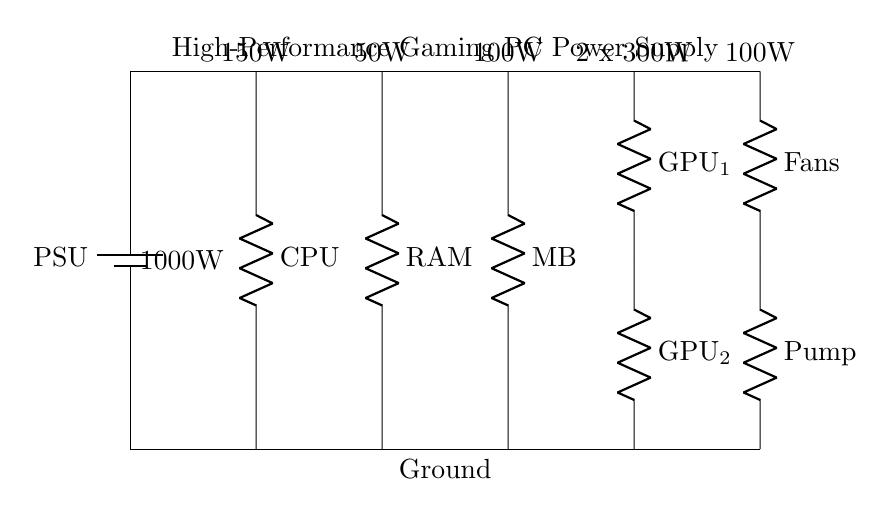what component provides power to the circuit? The component providing power to the circuit is the PSU, which stands for Power Supply Unit. This component is responsible for converting electrical power and distributing it to the various components of the gaming PC.
Answer: PSU how many GPUs are shown in the circuit diagram? The circuit diagram depicts two GPUs, labeled GPU_1 and GPU_2. Both are connected in series along the power rail.
Answer: 2 what is the total power rating of the GPUs? Each GPU has a power rating of 300W, so the total power for both GPUs is calculated by multiplying the power rating of one GPU by the number of GPUs: 300W x 2 = 600W.
Answer: 600W what is the power rating of the CPU in the circuit? The CPU's power rating is indicated as 150W in the diagram, which represents the amount of electrical power it requires for its operation.
Answer: 150W which component has the highest power rating? The component with the highest power rating in this circuit is the PSU, which has a rating of 1000W. This is the total power capacity available for the entire system.
Answer: 1000W how is the cooling system powered in this circuit? The cooling system, consisting of fans and a pump, receives power from the PSU as depicted in the circuit diagram. The fans are rated at 100W, and the pump also gets power from the same connection coming from the PSU.
Answer: PSU what is the total power consumption of the other components (excluding cooling and GPUs)? To calculate the total power consumption excluding the cooling system and GPUs, we add the power ratings of the CPU (150W), RAM (50W), and Motherboard (100W): 150W + 50W + 100W = 300W.
Answer: 300W 